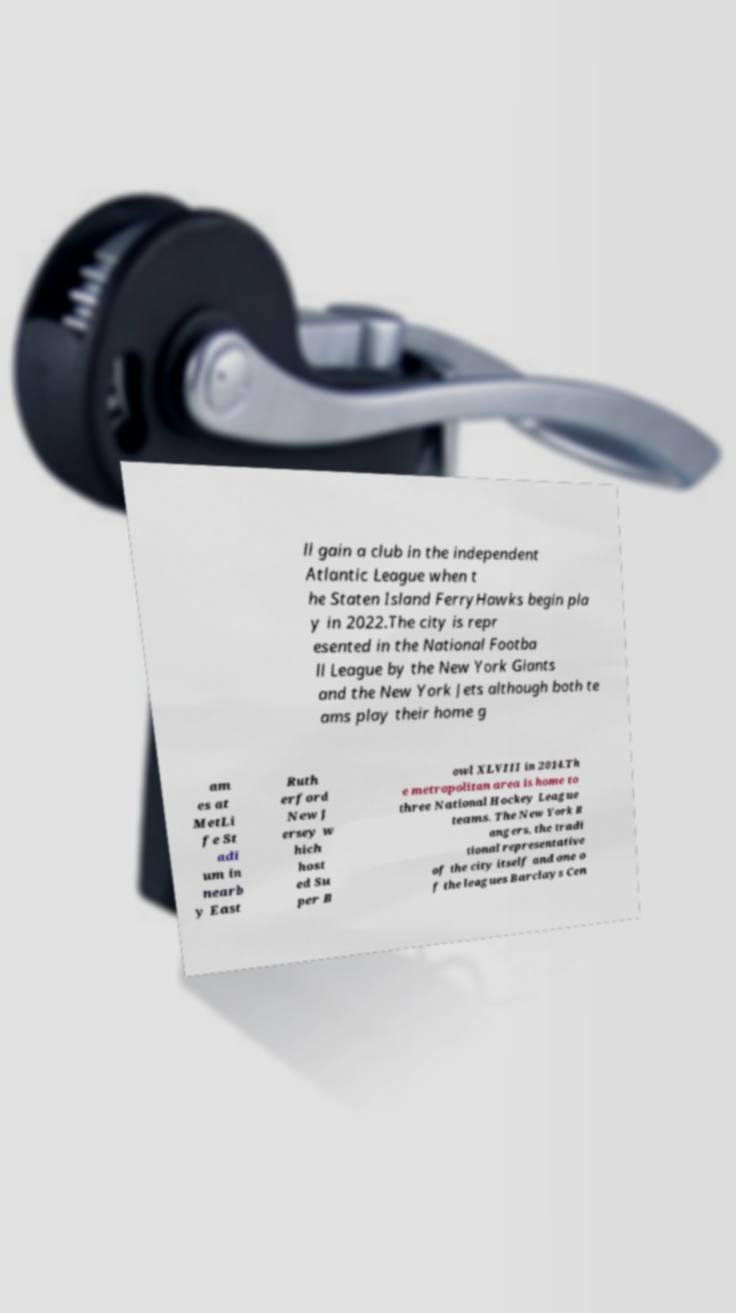I need the written content from this picture converted into text. Can you do that? ll gain a club in the independent Atlantic League when t he Staten Island FerryHawks begin pla y in 2022.The city is repr esented in the National Footba ll League by the New York Giants and the New York Jets although both te ams play their home g am es at MetLi fe St adi um in nearb y East Ruth erford New J ersey w hich host ed Su per B owl XLVIII in 2014.Th e metropolitan area is home to three National Hockey League teams. The New York R angers, the tradi tional representative of the city itself and one o f the leagues Barclays Cen 